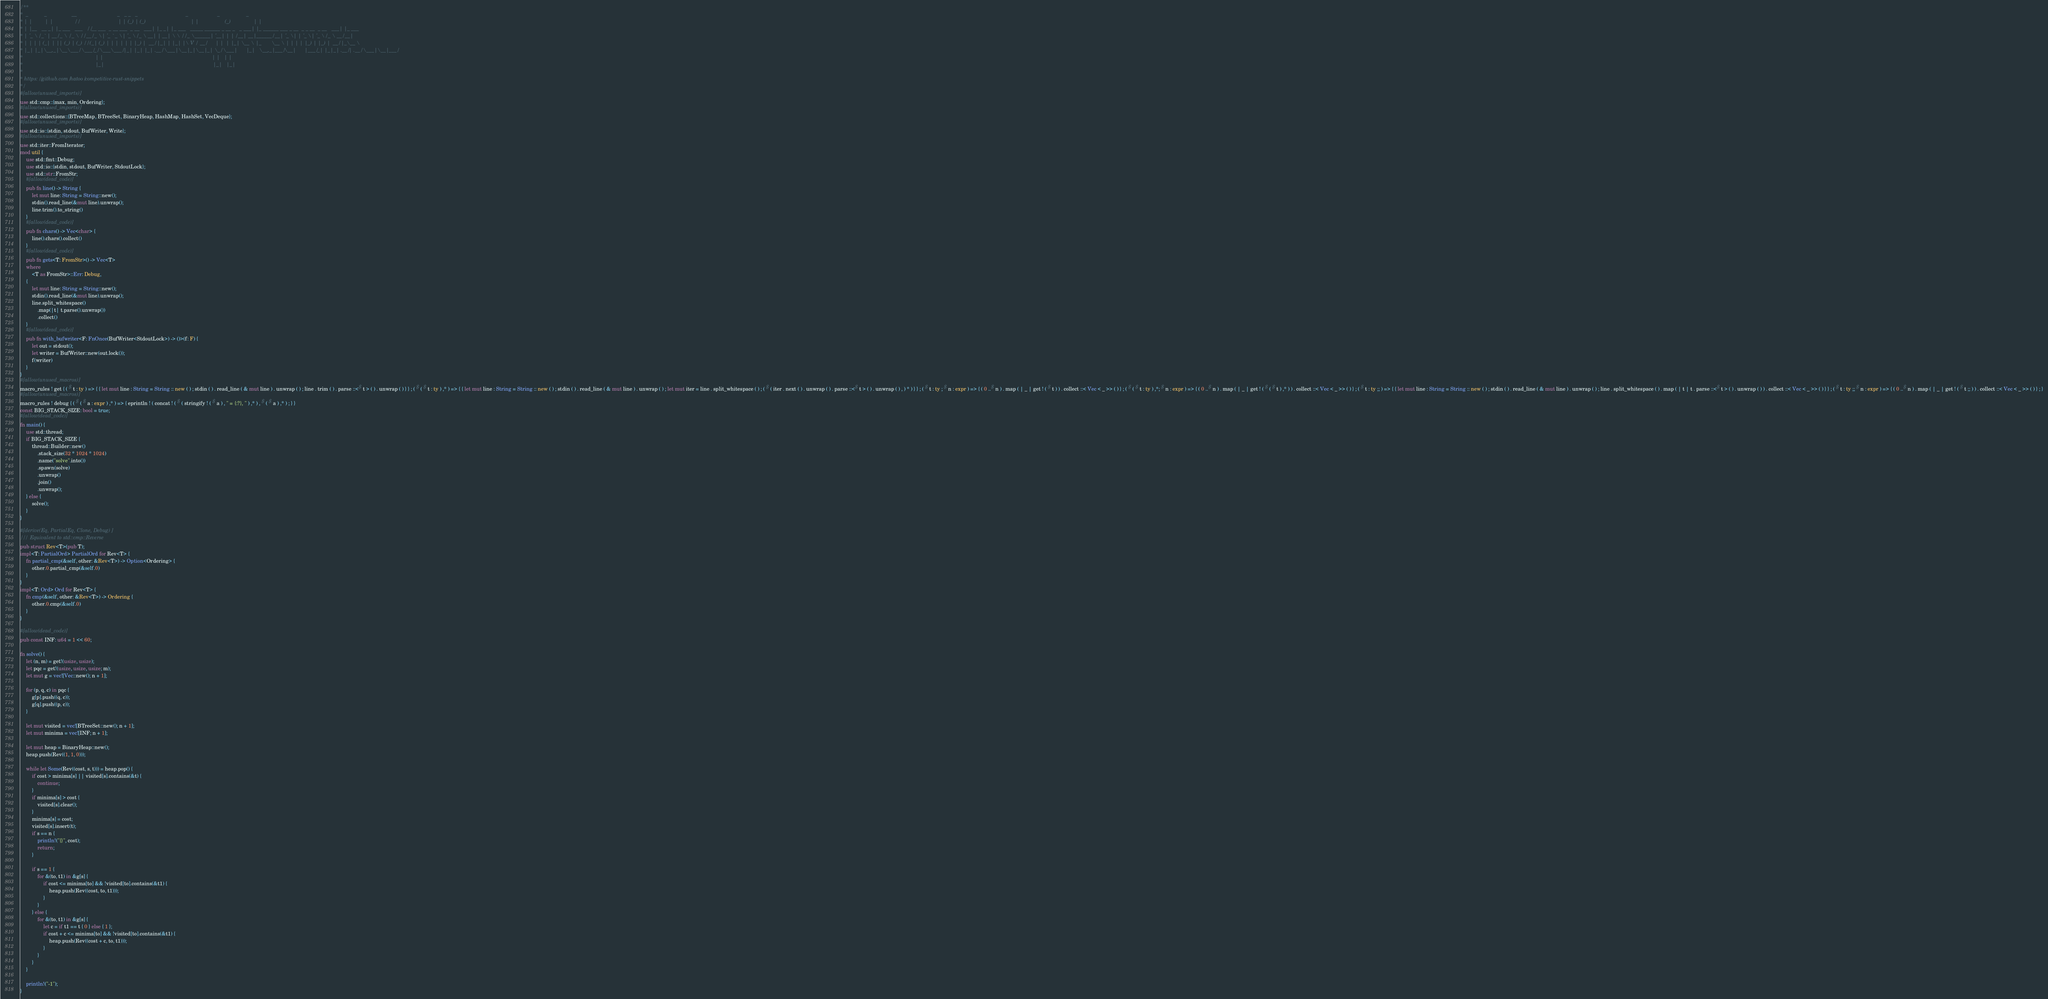<code> <loc_0><loc_0><loc_500><loc_500><_Rust_>/**
*  _           _                 __                            _   _ _   _                                 _                    _                  _
* | |         | |               / /                           | | (_) | (_)                               | |                  (_)                | |
* | |__   __ _| |_ ___   ___   / /__ ___  _ __ ___  _ __   ___| |_ _| |_ ___   _____ ______ _ __ _   _ ___| |_ ______ ___ _ __  _ _ __  _ __   ___| |_ ___
* | '_ \ / _` | __/ _ \ / _ \ / / __/ _ \| '_ ` _ \| '_ \ / _ \ __| | __| \ \ / / _ \______| '__| | | / __| __|______/ __| '_ \| | '_ \| '_ \ / _ \ __/ __|
* | | | | (_| | || (_) | (_) / / (_| (_) | | | | | | |_) |  __/ |_| | |_| |\ V /  __/      | |  | |_| \__ \ |_       \__ \ | | | | |_) | |_) |  __/ |_\__ \
* |_| |_|\__,_|\__\___/ \___/_/ \___\___/|_| |_| |_| .__/ \___|\__|_|\__|_| \_/ \___|      |_|   \__,_|___/\__|      |___/_| |_|_| .__/| .__/ \___|\__|___/
*                                                  | |                                                                           | |   | |
*                                                  |_|                                                                           |_|   |_|
*
* https://github.com/hatoo/competitive-rust-snippets
*/
#[allow(unused_imports)]
use std::cmp::{max, min, Ordering};
#[allow(unused_imports)]
use std::collections::{BTreeMap, BTreeSet, BinaryHeap, HashMap, HashSet, VecDeque};
#[allow(unused_imports)]
use std::io::{stdin, stdout, BufWriter, Write};
#[allow(unused_imports)]
use std::iter::FromIterator;
mod util {
    use std::fmt::Debug;
    use std::io::{stdin, stdout, BufWriter, StdoutLock};
    use std::str::FromStr;
    #[allow(dead_code)]
    pub fn line() -> String {
        let mut line: String = String::new();
        stdin().read_line(&mut line).unwrap();
        line.trim().to_string()
    }
    #[allow(dead_code)]
    pub fn chars() -> Vec<char> {
        line().chars().collect()
    }
    #[allow(dead_code)]
    pub fn gets<T: FromStr>() -> Vec<T>
    where
        <T as FromStr>::Err: Debug,
    {
        let mut line: String = String::new();
        stdin().read_line(&mut line).unwrap();
        line.split_whitespace()
            .map(|t| t.parse().unwrap())
            .collect()
    }
    #[allow(dead_code)]
    pub fn with_bufwriter<F: FnOnce(BufWriter<StdoutLock>) -> ()>(f: F) {
        let out = stdout();
        let writer = BufWriter::new(out.lock());
        f(writer)
    }
}
#[allow(unused_macros)]
macro_rules ! get { ( $ t : ty ) => { { let mut line : String = String :: new ( ) ; stdin ( ) . read_line ( & mut line ) . unwrap ( ) ; line . trim ( ) . parse ::<$ t > ( ) . unwrap ( ) } } ; ( $ ( $ t : ty ) ,* ) => { { let mut line : String = String :: new ( ) ; stdin ( ) . read_line ( & mut line ) . unwrap ( ) ; let mut iter = line . split_whitespace ( ) ; ( $ ( iter . next ( ) . unwrap ( ) . parse ::<$ t > ( ) . unwrap ( ) , ) * ) } } ; ( $ t : ty ; $ n : expr ) => { ( 0 ..$ n ) . map ( | _ | get ! ( $ t ) ) . collect ::< Vec < _ >> ( ) } ; ( $ ( $ t : ty ) ,*; $ n : expr ) => { ( 0 ..$ n ) . map ( | _ | get ! ( $ ( $ t ) ,* ) ) . collect ::< Vec < _ >> ( ) } ; ( $ t : ty ;; ) => { { let mut line : String = String :: new ( ) ; stdin ( ) . read_line ( & mut line ) . unwrap ( ) ; line . split_whitespace ( ) . map ( | t | t . parse ::<$ t > ( ) . unwrap ( ) ) . collect ::< Vec < _ >> ( ) } } ; ( $ t : ty ;; $ n : expr ) => { ( 0 ..$ n ) . map ( | _ | get ! ( $ t ;; ) ) . collect ::< Vec < _ >> ( ) } ; }
#[allow(unused_macros)]
macro_rules ! debug { ( $ ( $ a : expr ) ,* ) => { eprintln ! ( concat ! ( $ ( stringify ! ( $ a ) , " = {:?}, " ) ,* ) , $ ( $ a ) ,* ) ; } }
const BIG_STACK_SIZE: bool = true;
#[allow(dead_code)]
fn main() {
    use std::thread;
    if BIG_STACK_SIZE {
        thread::Builder::new()
            .stack_size(32 * 1024 * 1024)
            .name("solve".into())
            .spawn(solve)
            .unwrap()
            .join()
            .unwrap();
    } else {
        solve();
    }
}

#[derive(Eq, PartialEq, Clone, Debug)]
/// Equivalent to std::cmp::Reverse
pub struct Rev<T>(pub T);
impl<T: PartialOrd> PartialOrd for Rev<T> {
    fn partial_cmp(&self, other: &Rev<T>) -> Option<Ordering> {
        other.0.partial_cmp(&self.0)
    }
}
impl<T: Ord> Ord for Rev<T> {
    fn cmp(&self, other: &Rev<T>) -> Ordering {
        other.0.cmp(&self.0)
    }
}

#[allow(dead_code)]
pub const INF: u64 = 1 << 60;

fn solve() {
    let (n, m) = get!(usize, usize);
    let pqc = get!(usize, usize, usize; m);
    let mut g = vec![Vec::new(); n + 1];

    for (p, q, c) in pqc {
        g[p].push((q, c));
        g[q].push((p, c));
    }

    let mut visited = vec![BTreeSet::new(); n + 1];
    let mut minima = vec![INF; n + 1];

    let mut heap = BinaryHeap::new();
    heap.push(Rev((1, 1, 0)));

    while let Some(Rev((cost, s, t))) = heap.pop() {
        if cost > minima[s] || visited[s].contains(&t) {
            continue;
        }
        if minima[s] > cost {
            visited[s].clear();
        }
        minima[s] = cost;
        visited[s].insert(t);
        if s == n {
            println!("{}", cost);
            return;
        }

        if s == 1 {
            for &(to, t1) in &g[s] {
                if cost <= minima[to] && !visited[to].contains(&t1) {
                    heap.push(Rev((cost, to, t1)));
                }
            }
        } else {
            for &(to, t1) in &g[s] {
                let c = if t1 == t { 0 } else { 1 };
                if cost + c <= minima[to] && !visited[to].contains(&t1) {
                    heap.push(Rev((cost + c, to, t1)));
                }
            }
        }
    }

    println!("-1");
}
</code> 